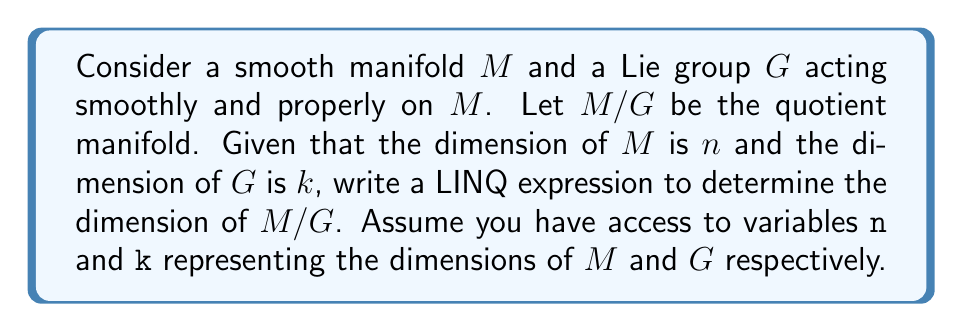Help me with this question. To solve this problem, we need to understand the relationship between the dimensions of $M$, $G$, and $M/G$. 

1. The quotient manifold $M/G$ is formed by identifying points in $M$ that are in the same orbit under the action of $G$.

2. The dimension of $M/G$ is equal to the dimension of $M$ minus the dimension of a typical orbit of $G$.

3. For a proper action of a Lie group, the dimension of a typical orbit is equal to the dimension of the group minus the dimension of a typical isotropy subgroup.

4. In the generic case, we assume that the action is free, meaning the isotropy subgroups are trivial (dimension 0).

5. Therefore, the dimension of $M/G$ is:

   $$\dim(M/G) = \dim(M) - \dim(G) = n - k$$

6. To express this using LINQ method syntax, we can use the `Select` method to perform the calculation:

   ```csharp
   var dimMG = new[] { n, k }.Select(dims => dims[0] - dims[1]).First();
   ```

   This creates an array with `n` and `k`, then uses `Select` to compute `n - k`, and `First()` to get the result.
Answer: The LINQ expression to determine the dimension of $M/G$ is:

```csharp
var dimMG = new[] { n, k }.Select(dims => dims[0] - dims[1]).First();
```

This will yield the value $n - k$, which is the dimension of the quotient manifold $M/G$. 